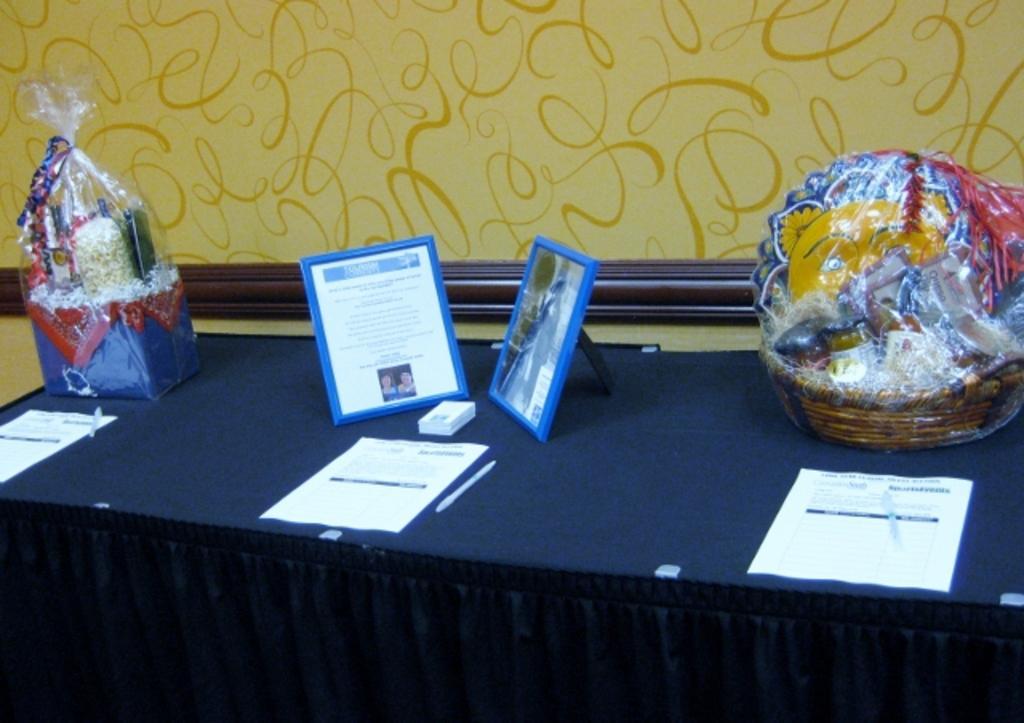How would you summarize this image in a sentence or two? In this image in the middle, there is a table on that there are papers, photo frames, baskets, gifts, cloth, pen, some other items. In the background there is a wall. 